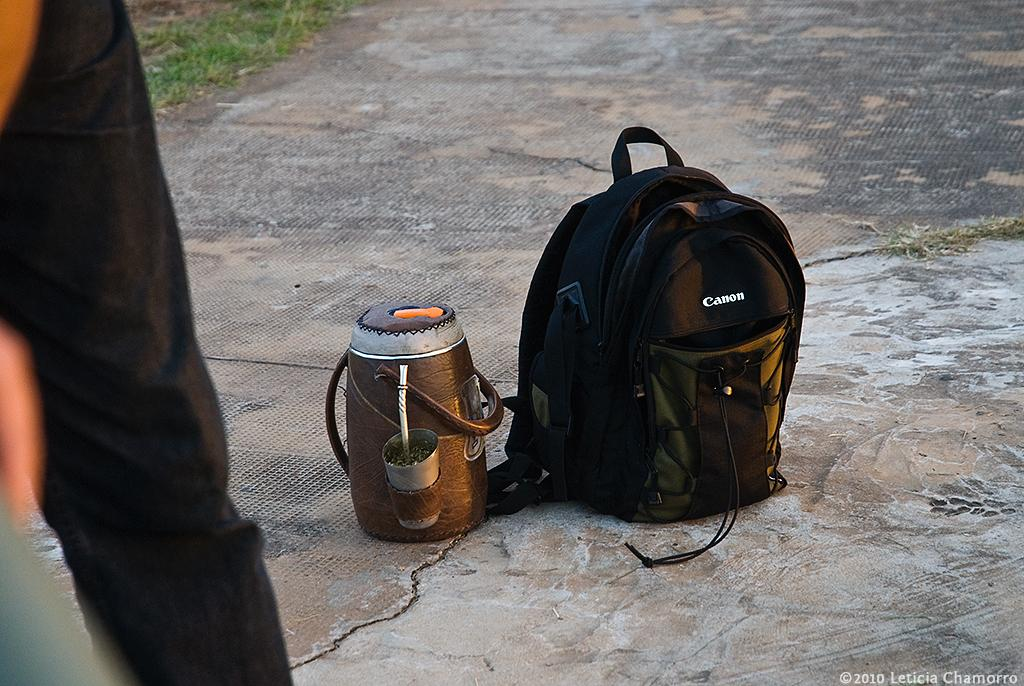<image>
Share a concise interpretation of the image provided. the word canon is on the back of the pack 